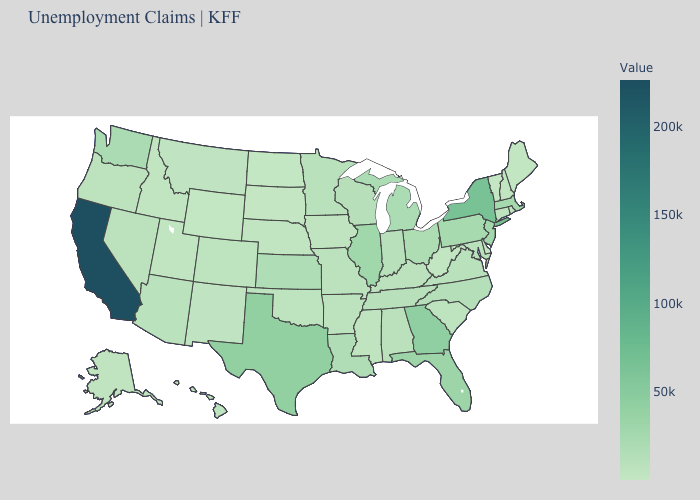Which states have the lowest value in the Northeast?
Give a very brief answer. Vermont. Among the states that border New Jersey , does New York have the lowest value?
Write a very short answer. No. Among the states that border Colorado , which have the lowest value?
Answer briefly. Wyoming. Does Illinois have a lower value than Mississippi?
Quick response, please. No. Does Louisiana have a higher value than California?
Give a very brief answer. No. 